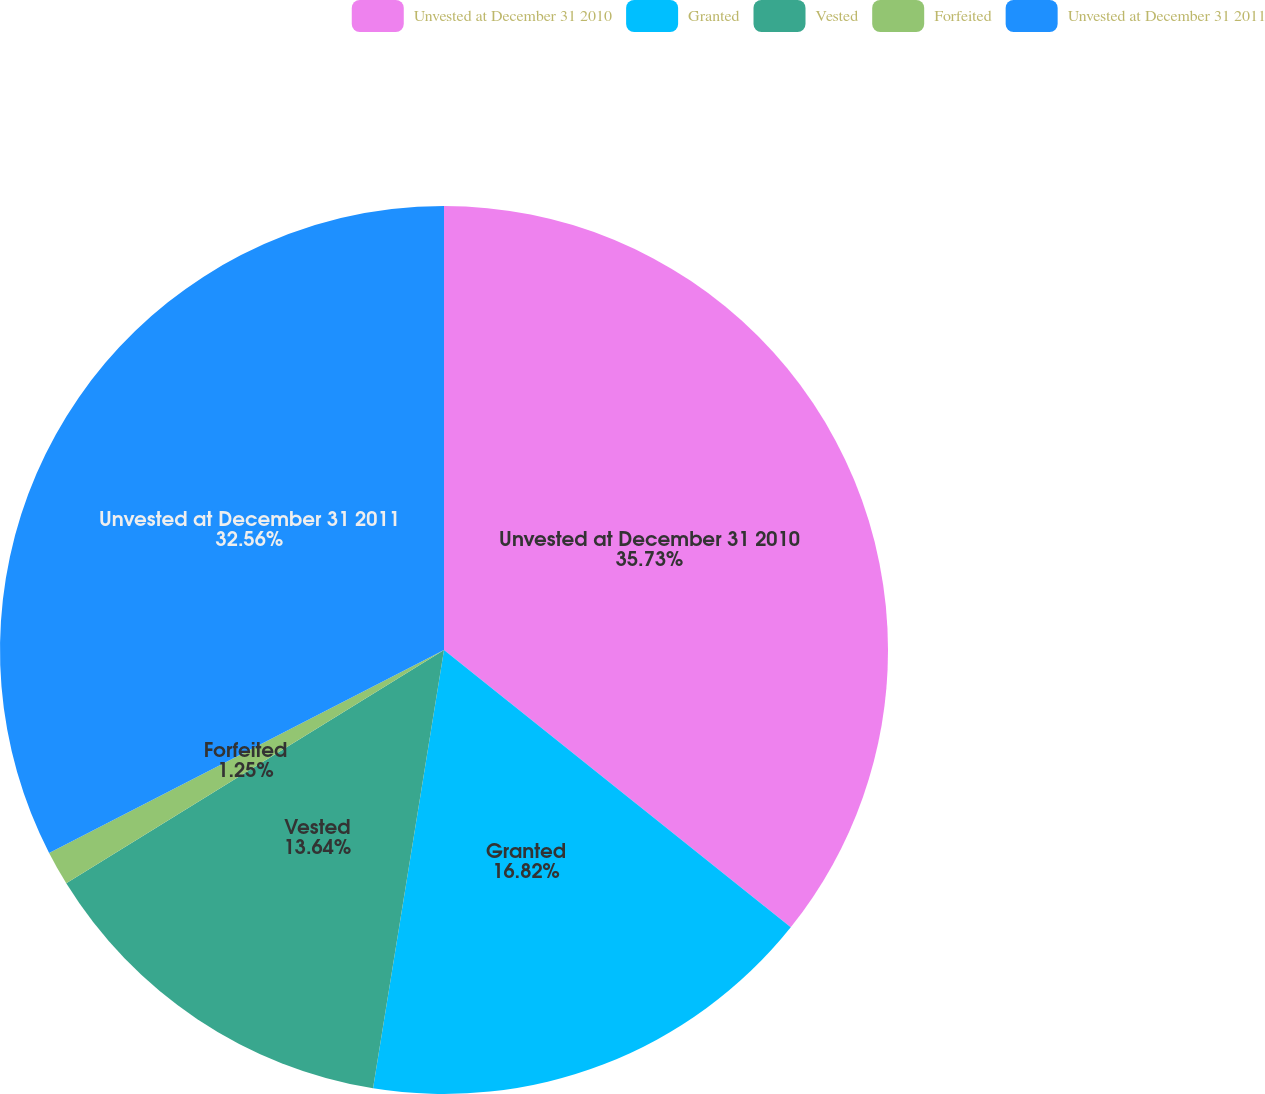Convert chart to OTSL. <chart><loc_0><loc_0><loc_500><loc_500><pie_chart><fcel>Unvested at December 31 2010<fcel>Granted<fcel>Vested<fcel>Forfeited<fcel>Unvested at December 31 2011<nl><fcel>35.74%<fcel>16.82%<fcel>13.64%<fcel>1.25%<fcel>32.56%<nl></chart> 